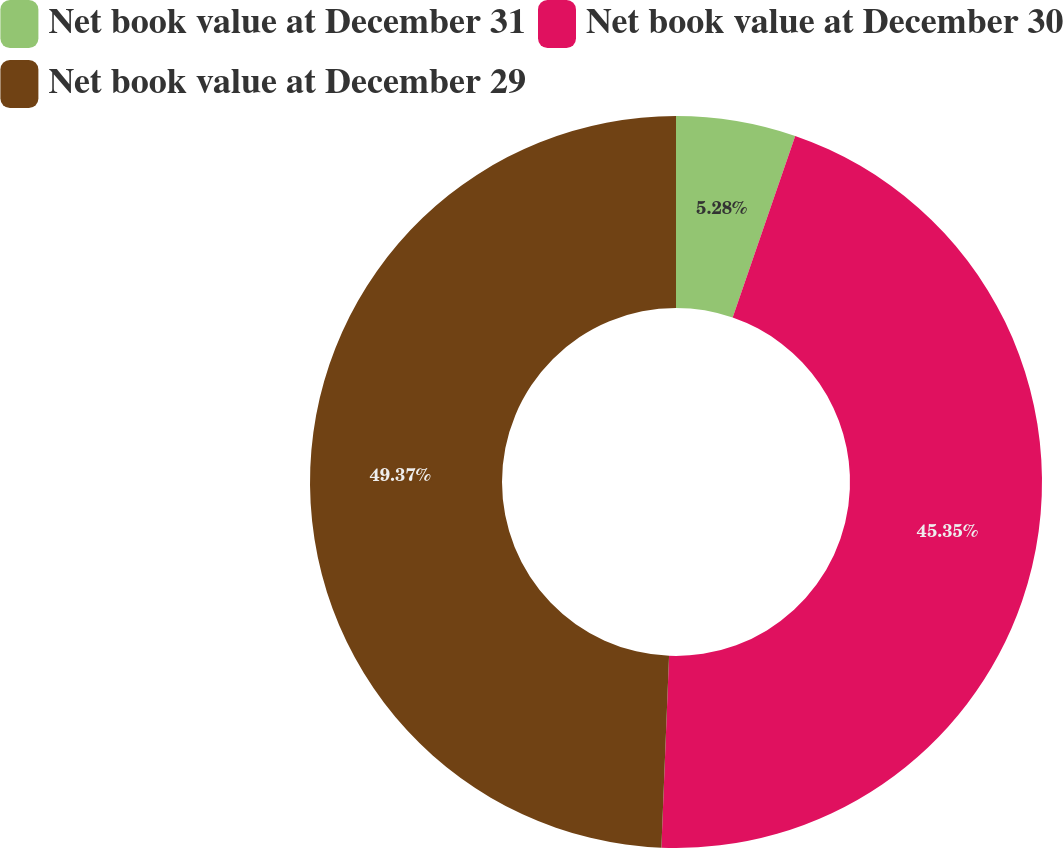Convert chart. <chart><loc_0><loc_0><loc_500><loc_500><pie_chart><fcel>Net book value at December 31<fcel>Net book value at December 30<fcel>Net book value at December 29<nl><fcel>5.28%<fcel>45.35%<fcel>49.36%<nl></chart> 